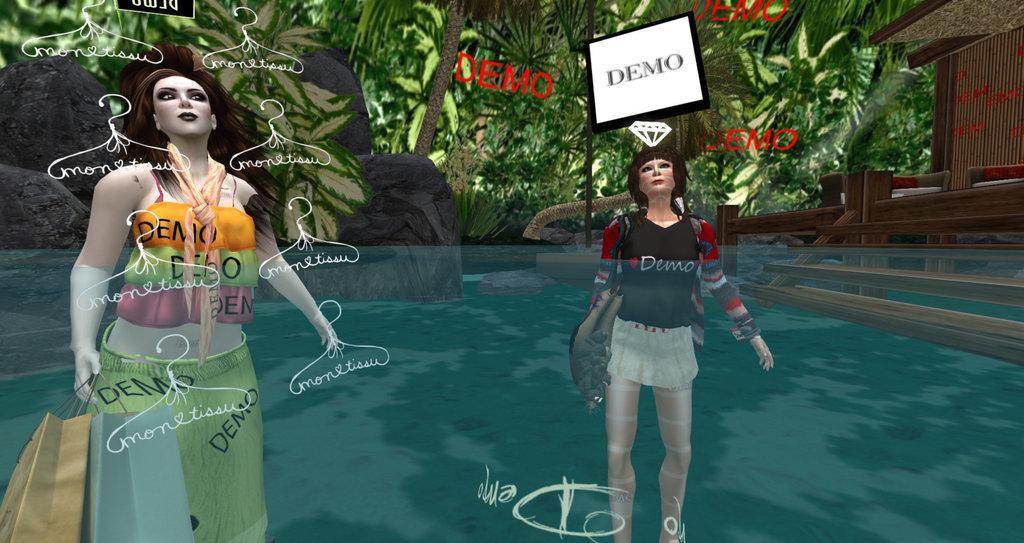Could you give a brief overview of what you see in this image? In the image there is a anime image of two ladies standing inside water an behind there are trees. 